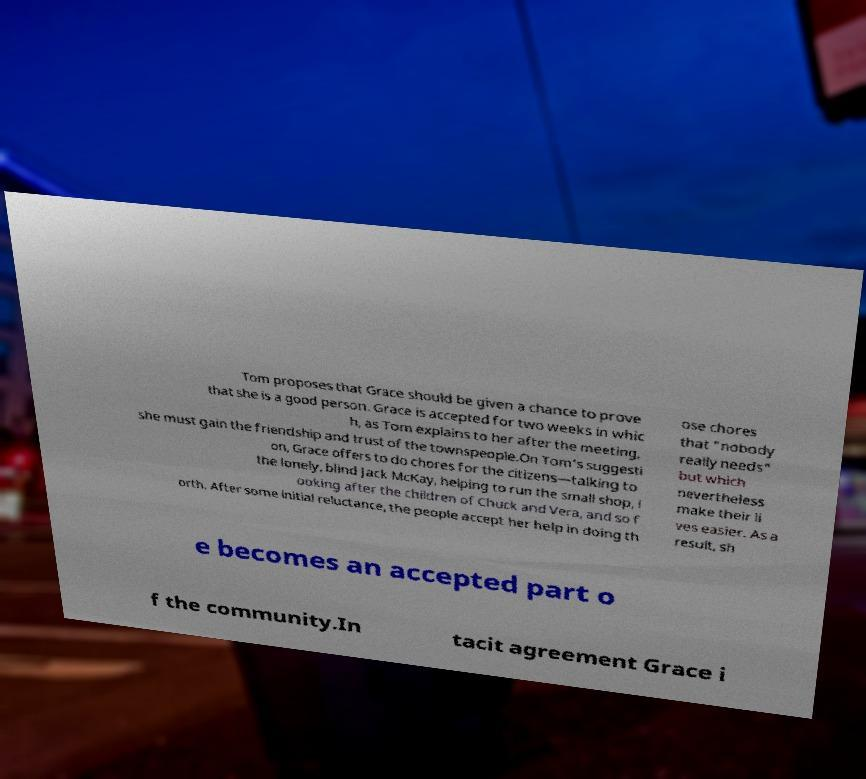Please read and relay the text visible in this image. What does it say? Tom proposes that Grace should be given a chance to prove that she is a good person. Grace is accepted for two weeks in whic h, as Tom explains to her after the meeting, she must gain the friendship and trust of the townspeople.On Tom's suggesti on, Grace offers to do chores for the citizens—talking to the lonely, blind Jack McKay, helping to run the small shop, l ooking after the children of Chuck and Vera, and so f orth. After some initial reluctance, the people accept her help in doing th ose chores that "nobody really needs" but which nevertheless make their li ves easier. As a result, sh e becomes an accepted part o f the community.In tacit agreement Grace i 